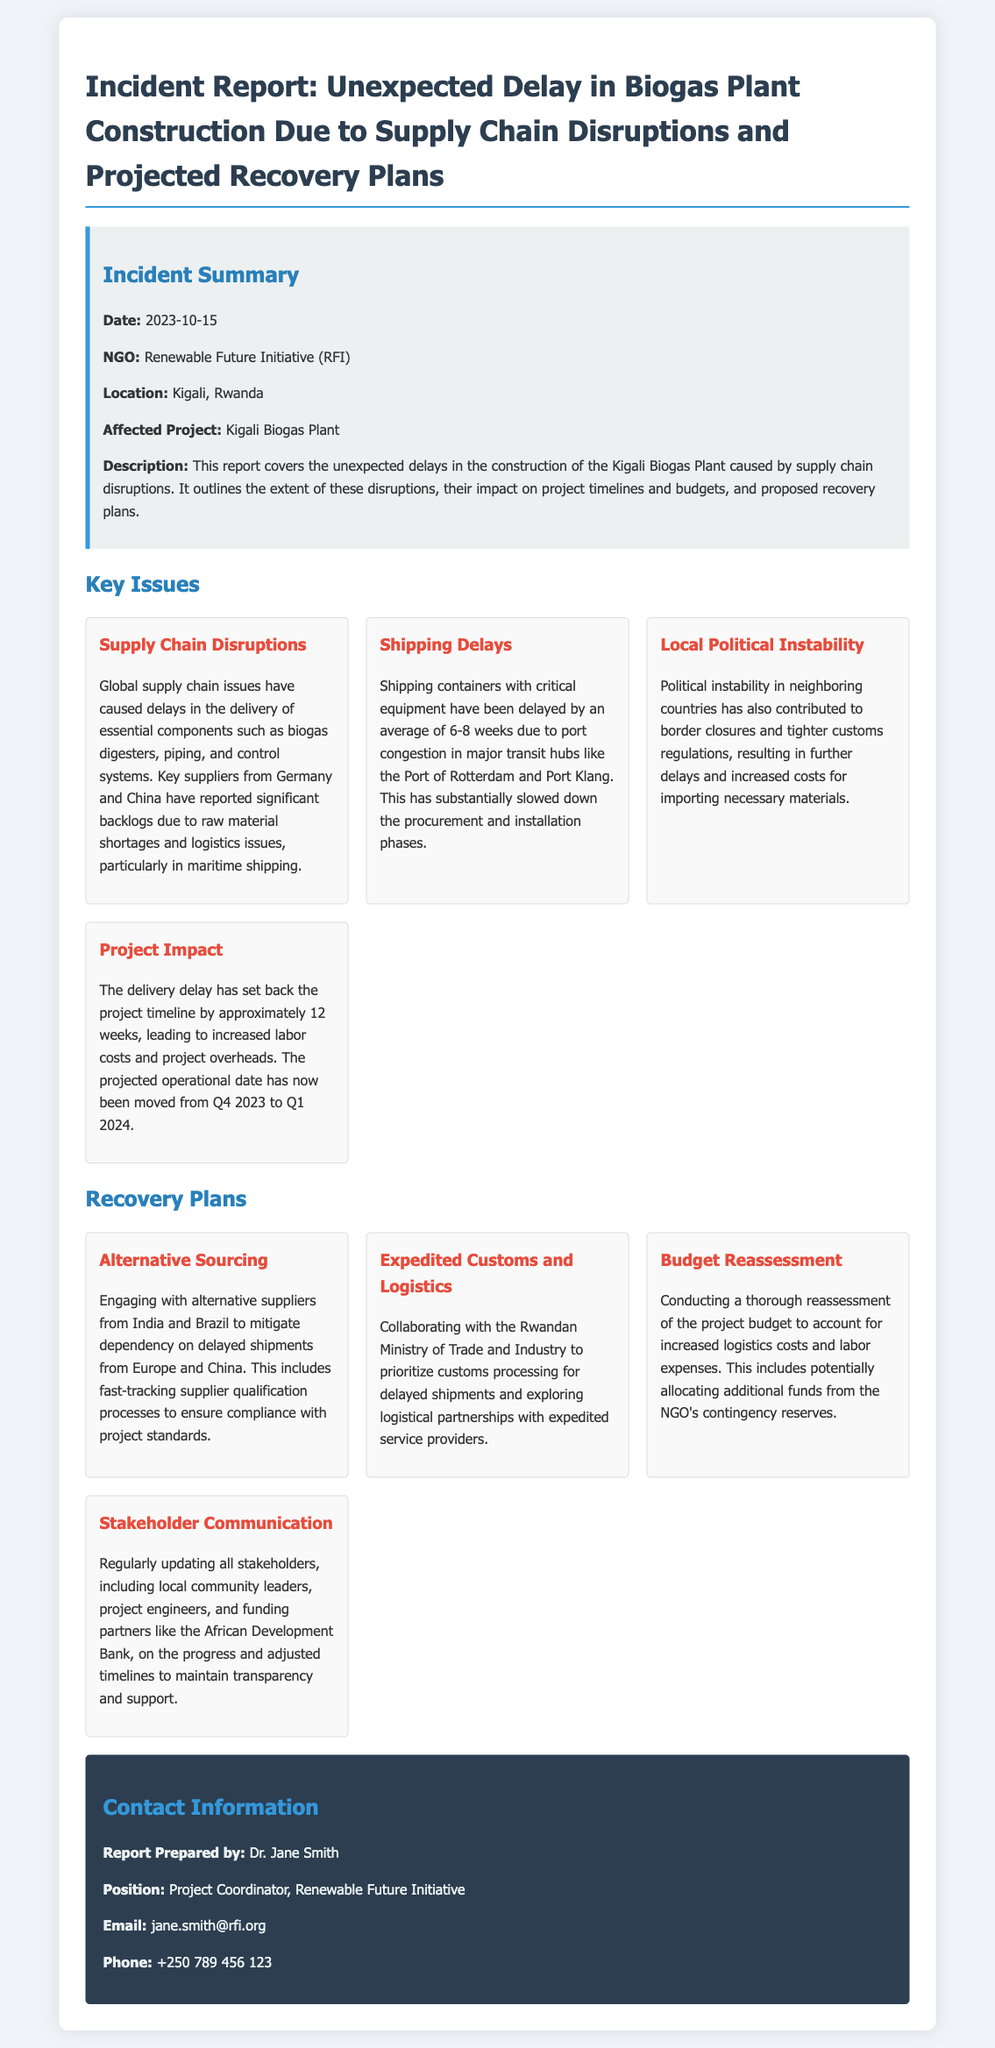what is the date of the incident report? The date of the incident report is provided in the summary section.
Answer: 2023-10-15 what organization is responsible for the report? The organization name is mentioned in the incident summary.
Answer: Renewable Future Initiative (RFI) where is the biogas plant located? The location of the project is specified in the document.
Answer: Kigali, Rwanda how many weeks has the project timeline been set back? The impact of the delay on the project timeline is discussed in the document.
Answer: 12 weeks what are the two key countries affected by supply chain issues? The countries of concern for supply chain disruptions are noted in the issues section.
Answer: Germany and China what is one of the proposed recovery plans? The document highlights several recovery plans, one of which is detailed for alternative sourcing.
Answer: Alternative Sourcing who is the project coordinator? The contact section provides the name of the individual in charge of the project.
Answer: Dr. Jane Smith what is the new projected operational date for the biogas plant? The revised operational date is mentioned in the description of project impact.
Answer: Q1 2024 how has local political instability affected the project? The report describes the influence of political instability in neighboring areas as a significant issue.
Answer: Border closures and tighter customs regulations 